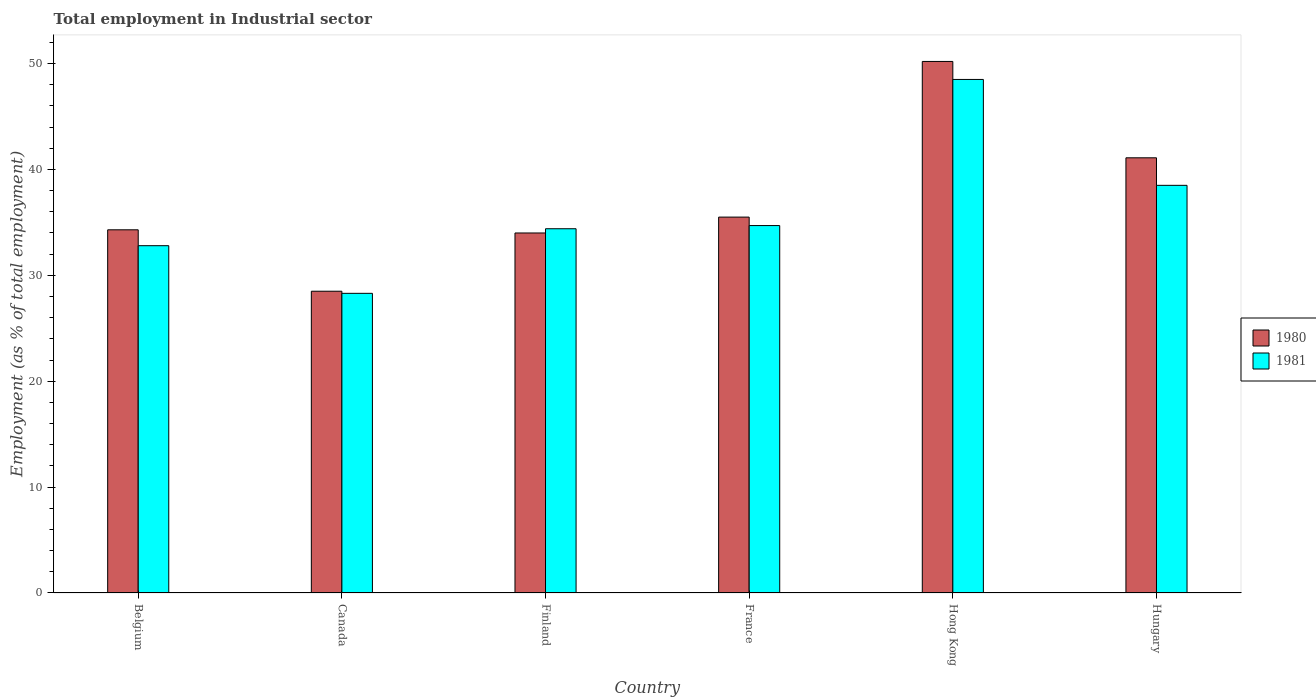How many different coloured bars are there?
Your answer should be very brief. 2. Are the number of bars per tick equal to the number of legend labels?
Your answer should be compact. Yes. Are the number of bars on each tick of the X-axis equal?
Provide a short and direct response. Yes. How many bars are there on the 1st tick from the left?
Your response must be concise. 2. What is the label of the 2nd group of bars from the left?
Offer a terse response. Canada. What is the employment in industrial sector in 1980 in Hungary?
Provide a succinct answer. 41.1. Across all countries, what is the maximum employment in industrial sector in 1981?
Make the answer very short. 48.5. Across all countries, what is the minimum employment in industrial sector in 1981?
Offer a very short reply. 28.3. In which country was the employment in industrial sector in 1980 maximum?
Provide a succinct answer. Hong Kong. In which country was the employment in industrial sector in 1981 minimum?
Offer a terse response. Canada. What is the total employment in industrial sector in 1980 in the graph?
Provide a short and direct response. 223.6. What is the difference between the employment in industrial sector in 1981 in France and that in Hong Kong?
Make the answer very short. -13.8. What is the difference between the employment in industrial sector in 1981 in Hungary and the employment in industrial sector in 1980 in Belgium?
Give a very brief answer. 4.2. What is the average employment in industrial sector in 1981 per country?
Your response must be concise. 36.2. What is the ratio of the employment in industrial sector in 1981 in Finland to that in Hong Kong?
Give a very brief answer. 0.71. Is the employment in industrial sector in 1980 in Canada less than that in Hong Kong?
Keep it short and to the point. Yes. What is the difference between the highest and the second highest employment in industrial sector in 1981?
Your response must be concise. 13.8. What is the difference between the highest and the lowest employment in industrial sector in 1980?
Offer a very short reply. 21.7. In how many countries, is the employment in industrial sector in 1981 greater than the average employment in industrial sector in 1981 taken over all countries?
Ensure brevity in your answer.  2. What does the 2nd bar from the left in Canada represents?
Make the answer very short. 1981. Are all the bars in the graph horizontal?
Offer a terse response. No. What is the difference between two consecutive major ticks on the Y-axis?
Your answer should be compact. 10. Are the values on the major ticks of Y-axis written in scientific E-notation?
Provide a short and direct response. No. What is the title of the graph?
Your response must be concise. Total employment in Industrial sector. What is the label or title of the Y-axis?
Offer a very short reply. Employment (as % of total employment). What is the Employment (as % of total employment) of 1980 in Belgium?
Give a very brief answer. 34.3. What is the Employment (as % of total employment) of 1981 in Belgium?
Offer a terse response. 32.8. What is the Employment (as % of total employment) of 1981 in Canada?
Make the answer very short. 28.3. What is the Employment (as % of total employment) in 1980 in Finland?
Offer a very short reply. 34. What is the Employment (as % of total employment) of 1981 in Finland?
Make the answer very short. 34.4. What is the Employment (as % of total employment) in 1980 in France?
Offer a very short reply. 35.5. What is the Employment (as % of total employment) in 1981 in France?
Ensure brevity in your answer.  34.7. What is the Employment (as % of total employment) of 1980 in Hong Kong?
Ensure brevity in your answer.  50.2. What is the Employment (as % of total employment) in 1981 in Hong Kong?
Give a very brief answer. 48.5. What is the Employment (as % of total employment) in 1980 in Hungary?
Give a very brief answer. 41.1. What is the Employment (as % of total employment) in 1981 in Hungary?
Provide a succinct answer. 38.5. Across all countries, what is the maximum Employment (as % of total employment) of 1980?
Your response must be concise. 50.2. Across all countries, what is the maximum Employment (as % of total employment) of 1981?
Ensure brevity in your answer.  48.5. Across all countries, what is the minimum Employment (as % of total employment) of 1980?
Provide a succinct answer. 28.5. Across all countries, what is the minimum Employment (as % of total employment) in 1981?
Your answer should be very brief. 28.3. What is the total Employment (as % of total employment) of 1980 in the graph?
Make the answer very short. 223.6. What is the total Employment (as % of total employment) of 1981 in the graph?
Make the answer very short. 217.2. What is the difference between the Employment (as % of total employment) of 1980 in Belgium and that in Finland?
Offer a terse response. 0.3. What is the difference between the Employment (as % of total employment) of 1981 in Belgium and that in Finland?
Keep it short and to the point. -1.6. What is the difference between the Employment (as % of total employment) of 1980 in Belgium and that in France?
Your answer should be very brief. -1.2. What is the difference between the Employment (as % of total employment) of 1980 in Belgium and that in Hong Kong?
Ensure brevity in your answer.  -15.9. What is the difference between the Employment (as % of total employment) of 1981 in Belgium and that in Hong Kong?
Provide a short and direct response. -15.7. What is the difference between the Employment (as % of total employment) in 1981 in Canada and that in Finland?
Make the answer very short. -6.1. What is the difference between the Employment (as % of total employment) of 1981 in Canada and that in France?
Give a very brief answer. -6.4. What is the difference between the Employment (as % of total employment) of 1980 in Canada and that in Hong Kong?
Give a very brief answer. -21.7. What is the difference between the Employment (as % of total employment) of 1981 in Canada and that in Hong Kong?
Provide a short and direct response. -20.2. What is the difference between the Employment (as % of total employment) in 1980 in Canada and that in Hungary?
Make the answer very short. -12.6. What is the difference between the Employment (as % of total employment) in 1980 in Finland and that in France?
Your answer should be very brief. -1.5. What is the difference between the Employment (as % of total employment) of 1980 in Finland and that in Hong Kong?
Ensure brevity in your answer.  -16.2. What is the difference between the Employment (as % of total employment) of 1981 in Finland and that in Hong Kong?
Your response must be concise. -14.1. What is the difference between the Employment (as % of total employment) in 1980 in France and that in Hong Kong?
Keep it short and to the point. -14.7. What is the difference between the Employment (as % of total employment) of 1980 in France and that in Hungary?
Your answer should be compact. -5.6. What is the difference between the Employment (as % of total employment) of 1981 in France and that in Hungary?
Provide a succinct answer. -3.8. What is the difference between the Employment (as % of total employment) in 1980 in Belgium and the Employment (as % of total employment) in 1981 in Canada?
Offer a very short reply. 6. What is the difference between the Employment (as % of total employment) in 1980 in Belgium and the Employment (as % of total employment) in 1981 in France?
Keep it short and to the point. -0.4. What is the difference between the Employment (as % of total employment) in 1980 in Belgium and the Employment (as % of total employment) in 1981 in Hungary?
Offer a terse response. -4.2. What is the difference between the Employment (as % of total employment) of 1980 in Canada and the Employment (as % of total employment) of 1981 in France?
Give a very brief answer. -6.2. What is the difference between the Employment (as % of total employment) in 1980 in Canada and the Employment (as % of total employment) in 1981 in Hong Kong?
Offer a very short reply. -20. What is the difference between the Employment (as % of total employment) of 1980 in Finland and the Employment (as % of total employment) of 1981 in France?
Keep it short and to the point. -0.7. What is the difference between the Employment (as % of total employment) in 1980 in France and the Employment (as % of total employment) in 1981 in Hong Kong?
Your answer should be compact. -13. What is the average Employment (as % of total employment) of 1980 per country?
Make the answer very short. 37.27. What is the average Employment (as % of total employment) in 1981 per country?
Your answer should be very brief. 36.2. What is the difference between the Employment (as % of total employment) in 1980 and Employment (as % of total employment) in 1981 in Canada?
Provide a short and direct response. 0.2. What is the difference between the Employment (as % of total employment) of 1980 and Employment (as % of total employment) of 1981 in France?
Provide a short and direct response. 0.8. What is the ratio of the Employment (as % of total employment) of 1980 in Belgium to that in Canada?
Your response must be concise. 1.2. What is the ratio of the Employment (as % of total employment) of 1981 in Belgium to that in Canada?
Give a very brief answer. 1.16. What is the ratio of the Employment (as % of total employment) in 1980 in Belgium to that in Finland?
Offer a very short reply. 1.01. What is the ratio of the Employment (as % of total employment) of 1981 in Belgium to that in Finland?
Offer a very short reply. 0.95. What is the ratio of the Employment (as % of total employment) of 1980 in Belgium to that in France?
Your answer should be very brief. 0.97. What is the ratio of the Employment (as % of total employment) of 1981 in Belgium to that in France?
Give a very brief answer. 0.95. What is the ratio of the Employment (as % of total employment) of 1980 in Belgium to that in Hong Kong?
Give a very brief answer. 0.68. What is the ratio of the Employment (as % of total employment) of 1981 in Belgium to that in Hong Kong?
Provide a short and direct response. 0.68. What is the ratio of the Employment (as % of total employment) of 1980 in Belgium to that in Hungary?
Your response must be concise. 0.83. What is the ratio of the Employment (as % of total employment) of 1981 in Belgium to that in Hungary?
Ensure brevity in your answer.  0.85. What is the ratio of the Employment (as % of total employment) of 1980 in Canada to that in Finland?
Provide a succinct answer. 0.84. What is the ratio of the Employment (as % of total employment) in 1981 in Canada to that in Finland?
Keep it short and to the point. 0.82. What is the ratio of the Employment (as % of total employment) in 1980 in Canada to that in France?
Provide a short and direct response. 0.8. What is the ratio of the Employment (as % of total employment) of 1981 in Canada to that in France?
Your response must be concise. 0.82. What is the ratio of the Employment (as % of total employment) in 1980 in Canada to that in Hong Kong?
Provide a short and direct response. 0.57. What is the ratio of the Employment (as % of total employment) of 1981 in Canada to that in Hong Kong?
Provide a succinct answer. 0.58. What is the ratio of the Employment (as % of total employment) in 1980 in Canada to that in Hungary?
Offer a very short reply. 0.69. What is the ratio of the Employment (as % of total employment) of 1981 in Canada to that in Hungary?
Offer a terse response. 0.74. What is the ratio of the Employment (as % of total employment) of 1980 in Finland to that in France?
Ensure brevity in your answer.  0.96. What is the ratio of the Employment (as % of total employment) in 1980 in Finland to that in Hong Kong?
Keep it short and to the point. 0.68. What is the ratio of the Employment (as % of total employment) of 1981 in Finland to that in Hong Kong?
Offer a very short reply. 0.71. What is the ratio of the Employment (as % of total employment) of 1980 in Finland to that in Hungary?
Make the answer very short. 0.83. What is the ratio of the Employment (as % of total employment) in 1981 in Finland to that in Hungary?
Provide a succinct answer. 0.89. What is the ratio of the Employment (as % of total employment) in 1980 in France to that in Hong Kong?
Your answer should be compact. 0.71. What is the ratio of the Employment (as % of total employment) in 1981 in France to that in Hong Kong?
Your answer should be very brief. 0.72. What is the ratio of the Employment (as % of total employment) in 1980 in France to that in Hungary?
Make the answer very short. 0.86. What is the ratio of the Employment (as % of total employment) of 1981 in France to that in Hungary?
Ensure brevity in your answer.  0.9. What is the ratio of the Employment (as % of total employment) of 1980 in Hong Kong to that in Hungary?
Your response must be concise. 1.22. What is the ratio of the Employment (as % of total employment) of 1981 in Hong Kong to that in Hungary?
Provide a succinct answer. 1.26. What is the difference between the highest and the second highest Employment (as % of total employment) in 1981?
Provide a succinct answer. 10. What is the difference between the highest and the lowest Employment (as % of total employment) of 1980?
Offer a terse response. 21.7. What is the difference between the highest and the lowest Employment (as % of total employment) in 1981?
Your answer should be very brief. 20.2. 